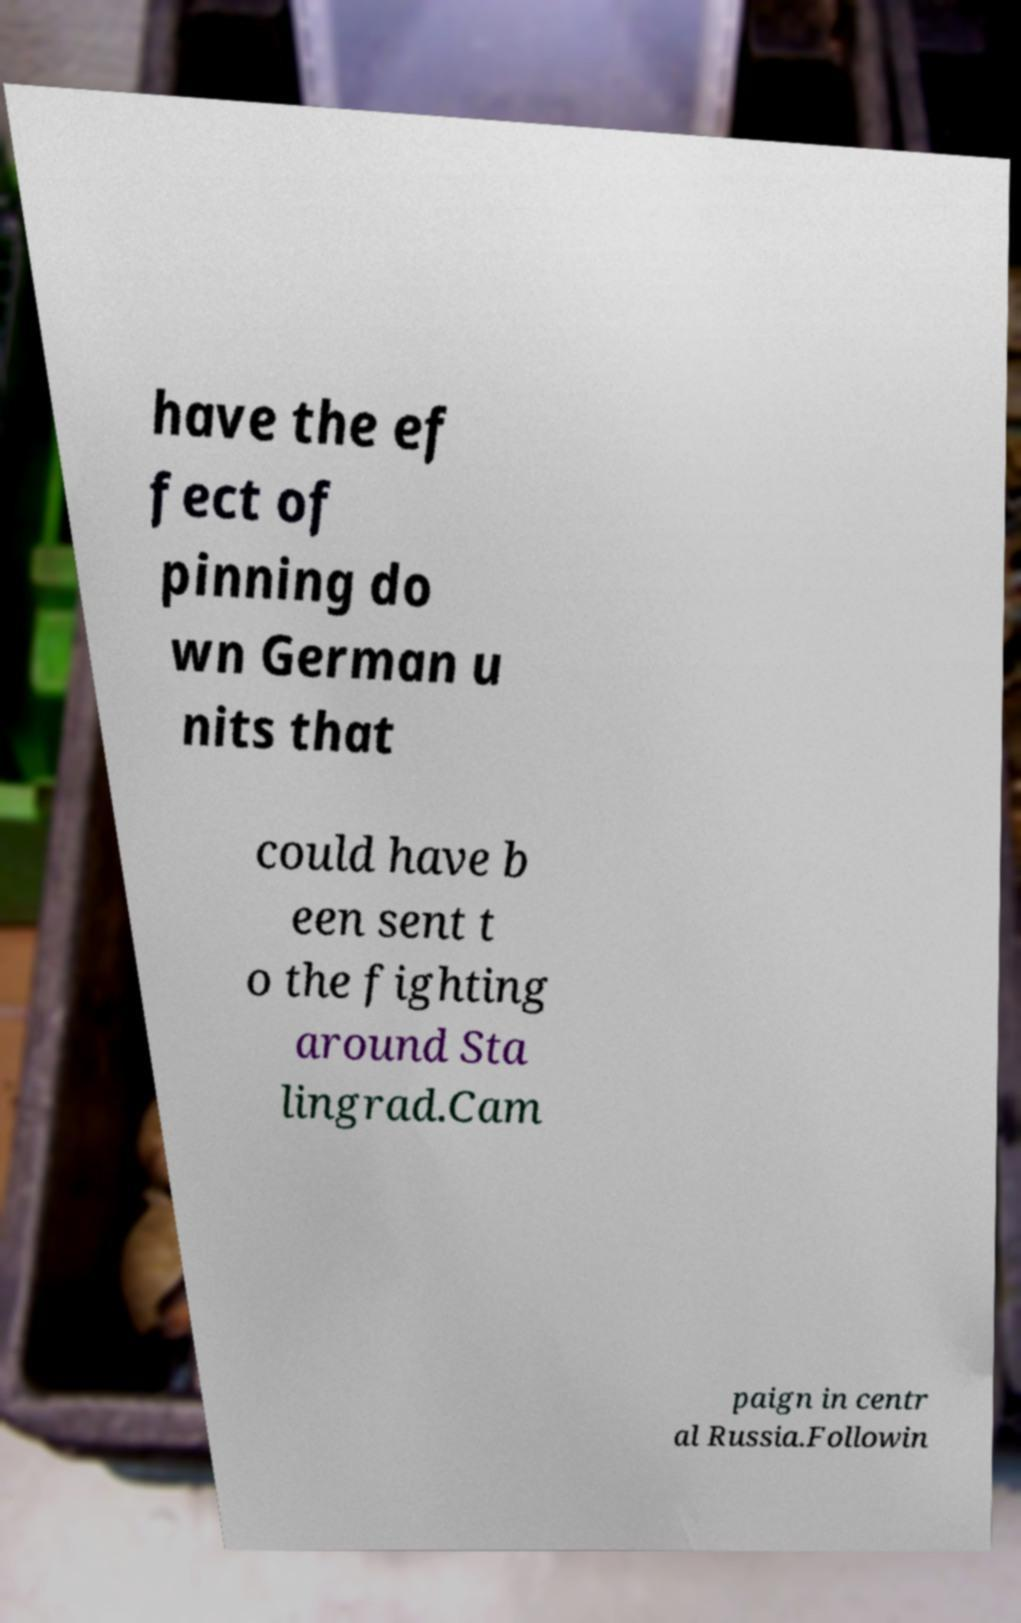Could you extract and type out the text from this image? have the ef fect of pinning do wn German u nits that could have b een sent t o the fighting around Sta lingrad.Cam paign in centr al Russia.Followin 